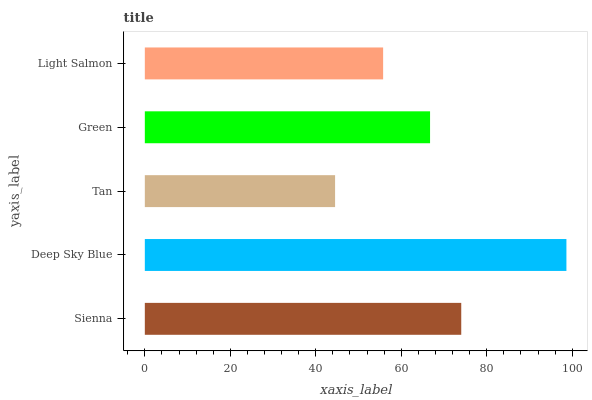Is Tan the minimum?
Answer yes or no. Yes. Is Deep Sky Blue the maximum?
Answer yes or no. Yes. Is Deep Sky Blue the minimum?
Answer yes or no. No. Is Tan the maximum?
Answer yes or no. No. Is Deep Sky Blue greater than Tan?
Answer yes or no. Yes. Is Tan less than Deep Sky Blue?
Answer yes or no. Yes. Is Tan greater than Deep Sky Blue?
Answer yes or no. No. Is Deep Sky Blue less than Tan?
Answer yes or no. No. Is Green the high median?
Answer yes or no. Yes. Is Green the low median?
Answer yes or no. Yes. Is Sienna the high median?
Answer yes or no. No. Is Deep Sky Blue the low median?
Answer yes or no. No. 